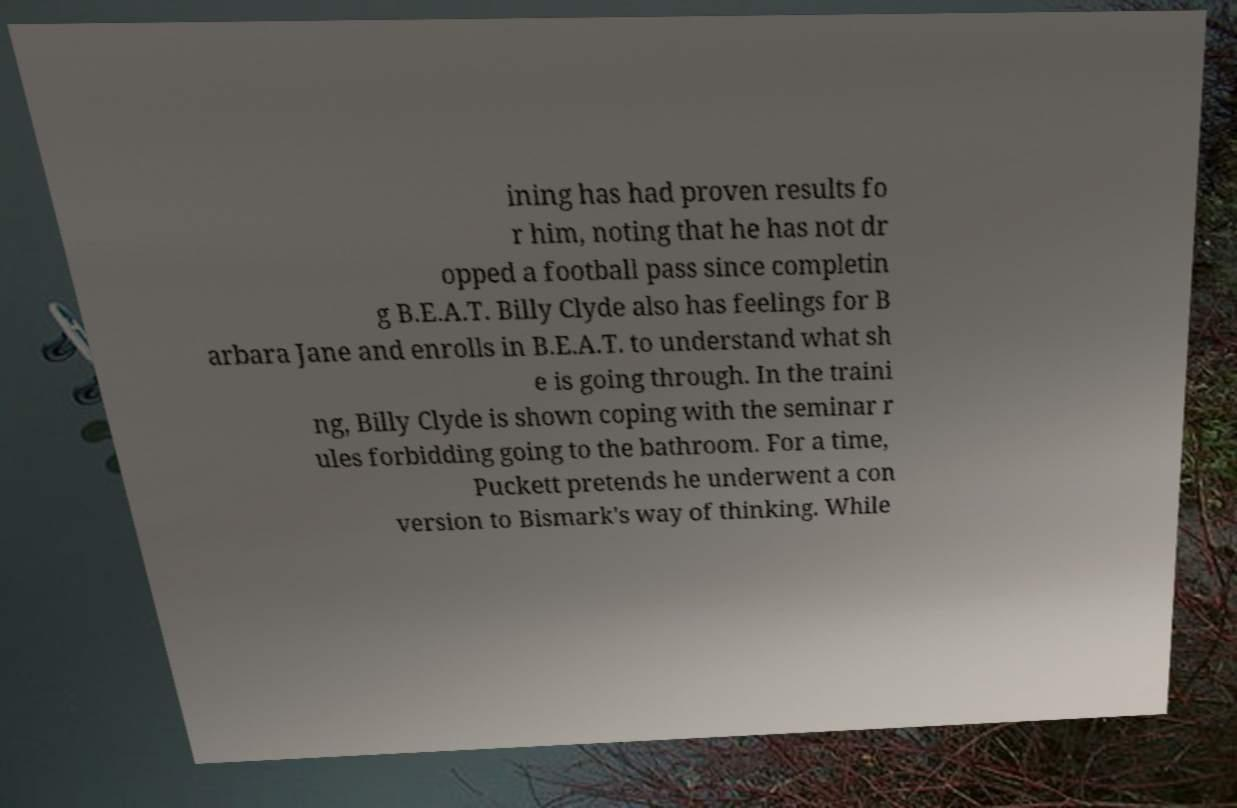Can you read and provide the text displayed in the image?This photo seems to have some interesting text. Can you extract and type it out for me? ining has had proven results fo r him, noting that he has not dr opped a football pass since completin g B.E.A.T. Billy Clyde also has feelings for B arbara Jane and enrolls in B.E.A.T. to understand what sh e is going through. In the traini ng, Billy Clyde is shown coping with the seminar r ules forbidding going to the bathroom. For a time, Puckett pretends he underwent a con version to Bismark's way of thinking. While 